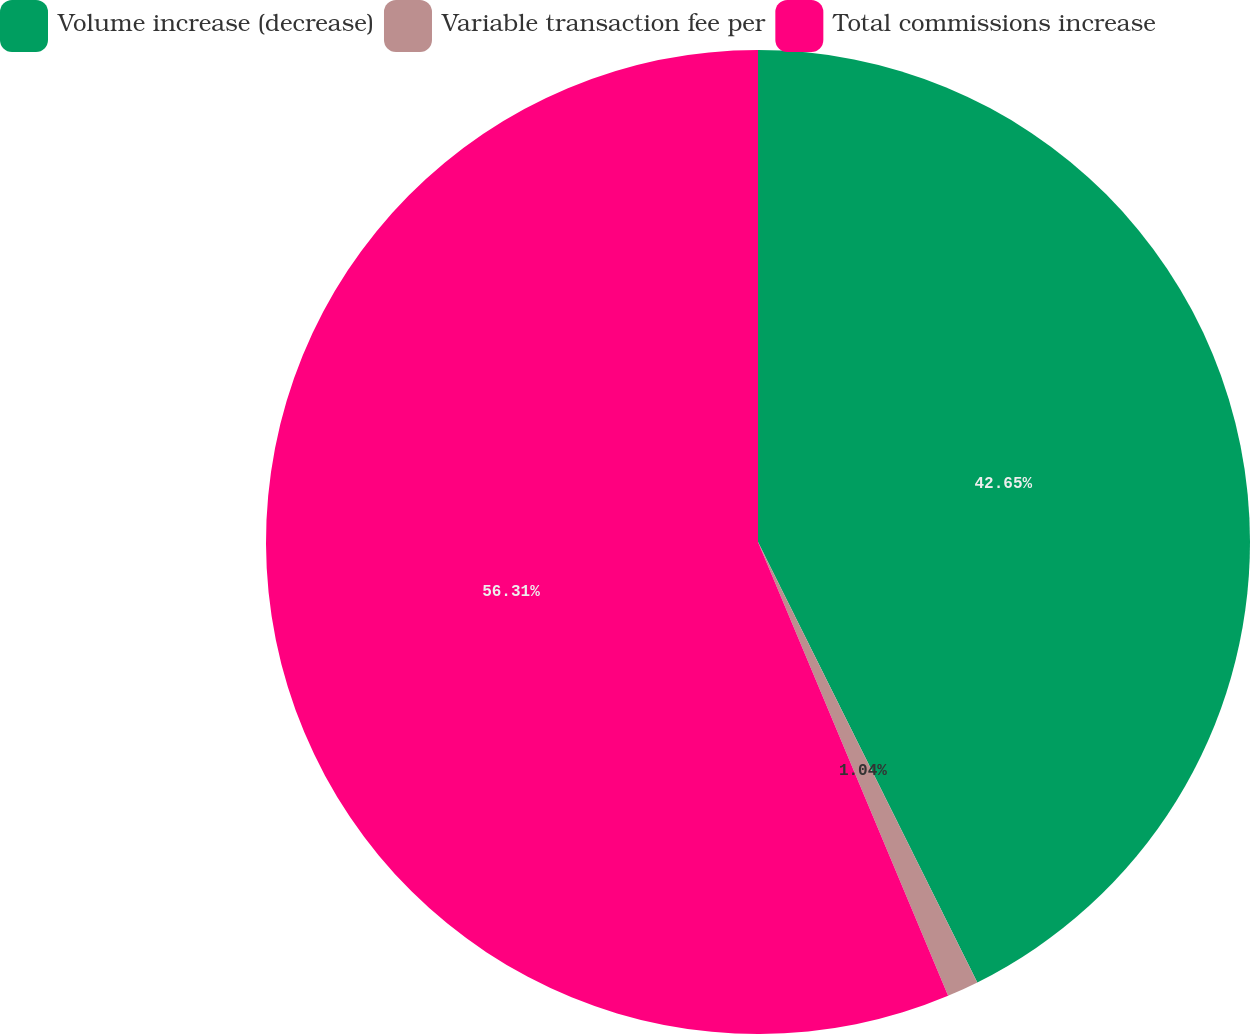Convert chart to OTSL. <chart><loc_0><loc_0><loc_500><loc_500><pie_chart><fcel>Volume increase (decrease)<fcel>Variable transaction fee per<fcel>Total commissions increase<nl><fcel>42.65%<fcel>1.04%<fcel>56.32%<nl></chart> 